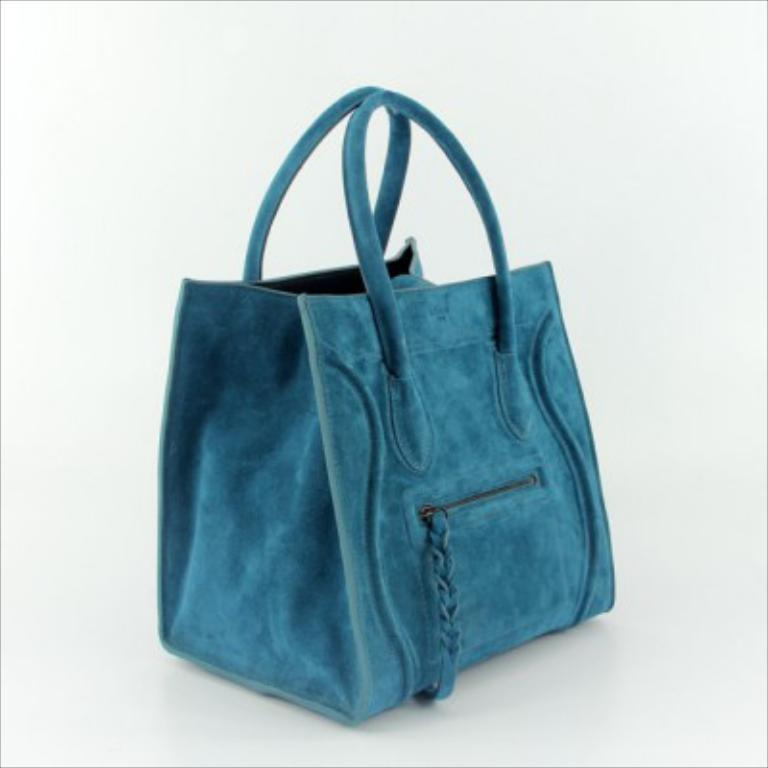Describe this image in one or two sentences. In this image there is a beautiful blue color handbag. 